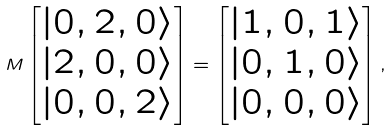<formula> <loc_0><loc_0><loc_500><loc_500>M \begin{bmatrix} | 0 , 2 , 0 \rangle \\ | 2 , 0 , 0 \rangle \\ | 0 , 0 , 2 \rangle \end{bmatrix} = \begin{bmatrix} | 1 , 0 , 1 \rangle \\ | 0 , 1 , 0 \rangle \\ | 0 , 0 , 0 \rangle \end{bmatrix} ,</formula> 